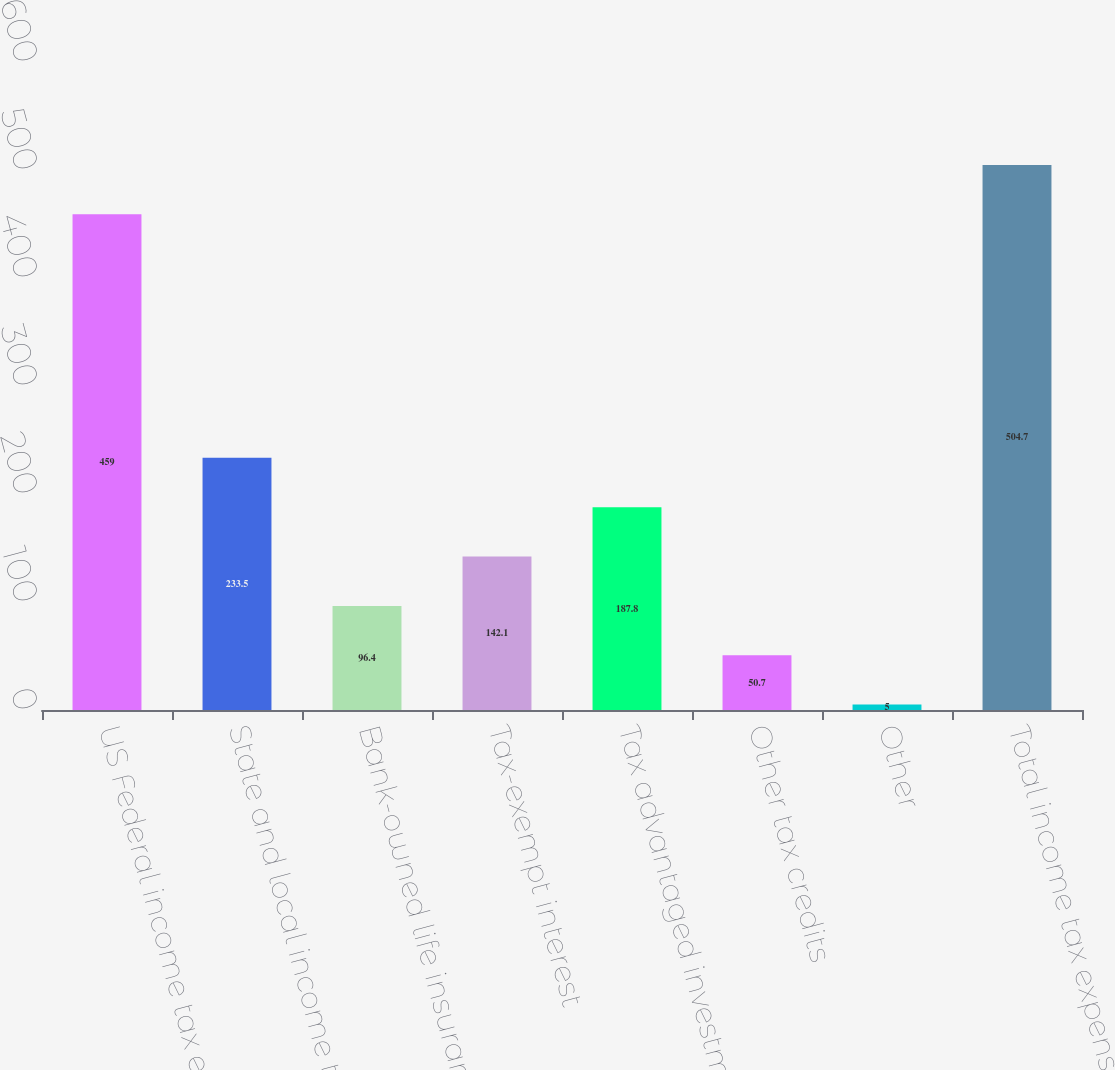Convert chart to OTSL. <chart><loc_0><loc_0><loc_500><loc_500><bar_chart><fcel>US Federal income tax expense<fcel>State and local income taxes<fcel>Bank-owned life insurance<fcel>Tax-exempt interest<fcel>Tax advantaged investments<fcel>Other tax credits<fcel>Other<fcel>Total income tax expense and<nl><fcel>459<fcel>233.5<fcel>96.4<fcel>142.1<fcel>187.8<fcel>50.7<fcel>5<fcel>504.7<nl></chart> 